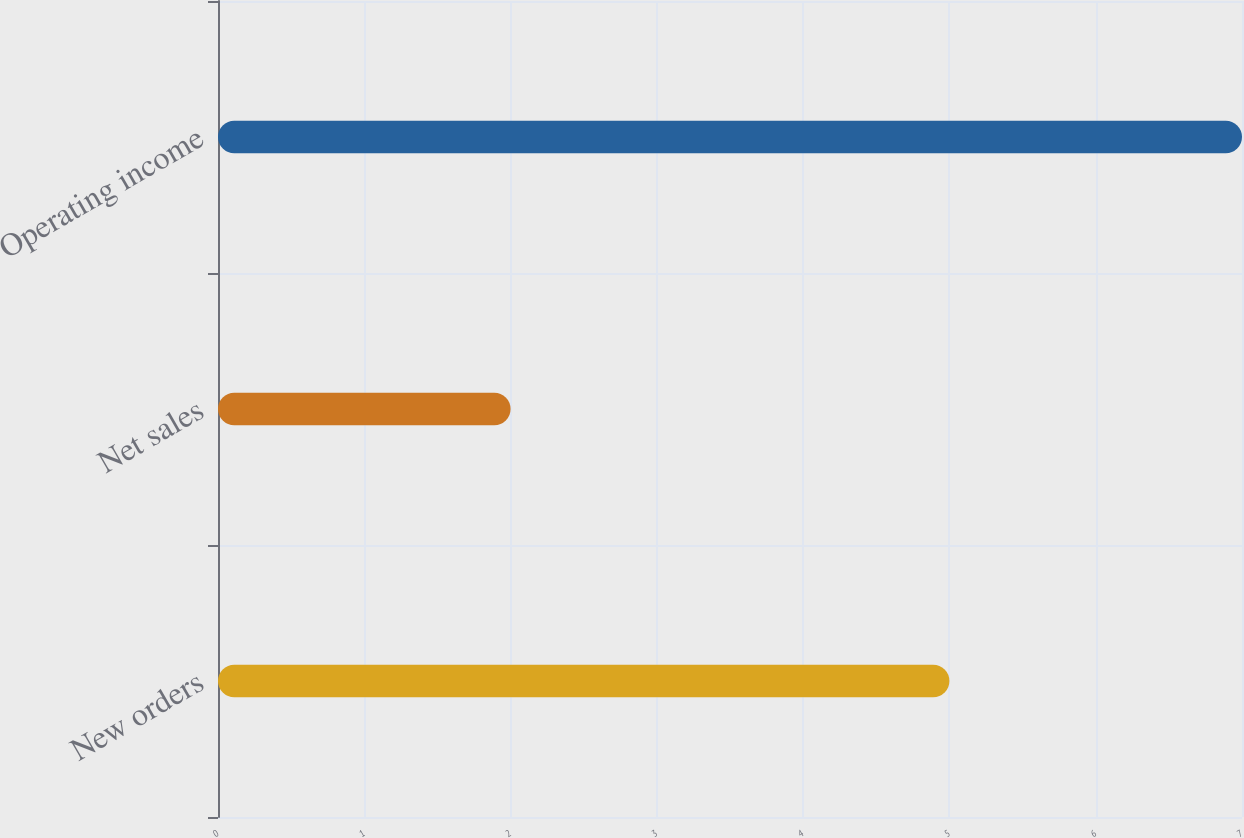Convert chart to OTSL. <chart><loc_0><loc_0><loc_500><loc_500><bar_chart><fcel>New orders<fcel>Net sales<fcel>Operating income<nl><fcel>5<fcel>2<fcel>7<nl></chart> 